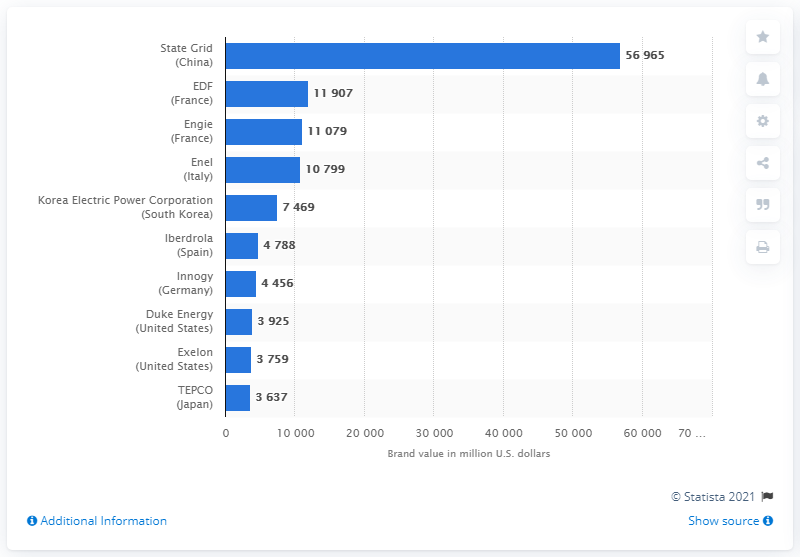Indicate a few pertinent items in this graphic. Iberdrola's brand value was $4,788 in dollars. 